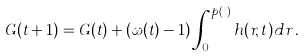<formula> <loc_0><loc_0><loc_500><loc_500>G ( t + 1 ) = G ( t ) + ( \omega ( t ) - 1 ) \int _ { 0 } ^ { p ( t ) } h ( r , t ) d r \, .</formula> 